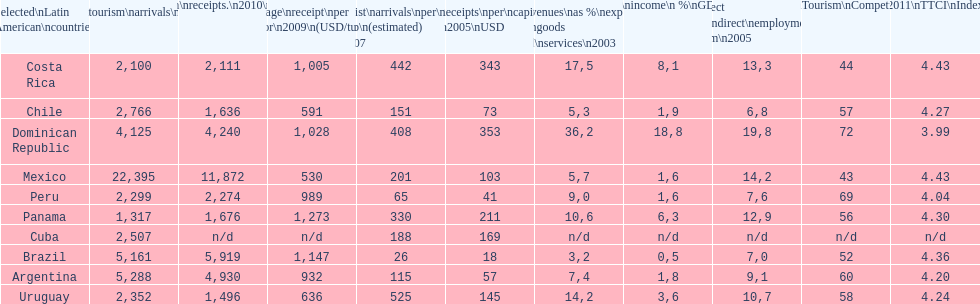How does brazil rank in average receipts per visitor in 2009? 1,147. 